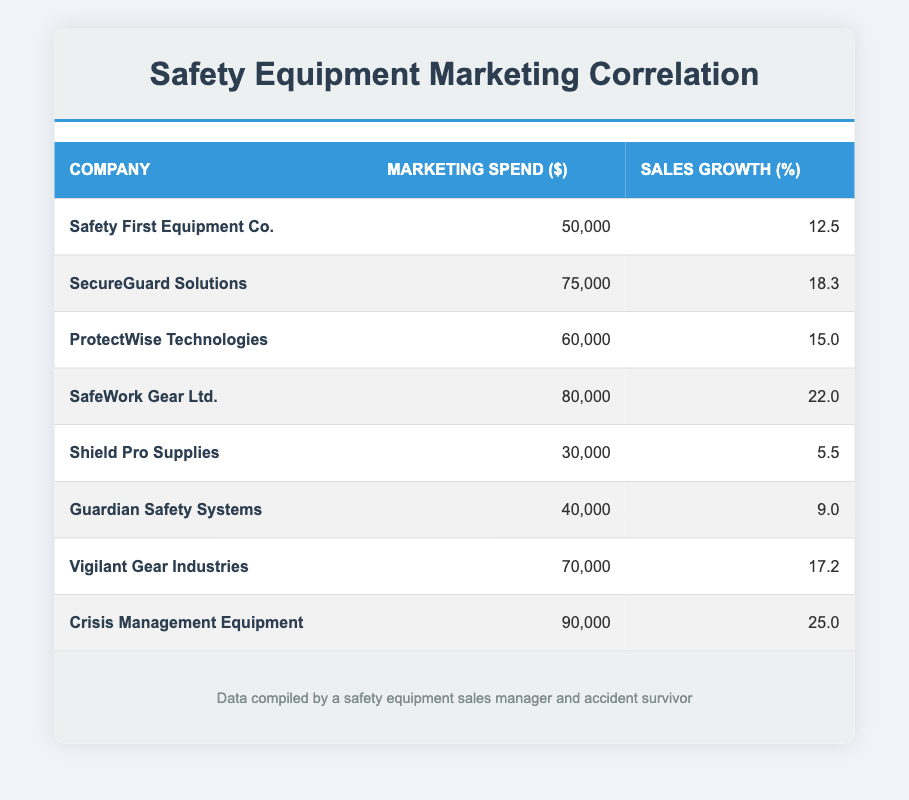What is the marketing spend for SafeWork Gear Ltd.? The table lists SafeWork Gear Ltd. with a marketing spend of $80,000.
Answer: 80,000 Which company has the highest sales growth? The table reveals that Crisis Management Equipment has the highest sales growth at 25.0%.
Answer: 25.0% What is the total marketing spend for the companies with sales growth above 15%? Identify the companies with sales growth above 15%: SecureGuard Solutions (75,000), SafeWork Gear Ltd. (80,000), Vigilant Gear Industries (70,000), and Crisis Management Equipment (90,000). Adding these, the total is 75,000 + 80,000 + 70,000 + 90,000 = 315,000.
Answer: 315,000 Is there a company with marketing spend of exactly 60,000? The table lists ProtectWise Technologies with a marketing spend of $60,000, confirming that this fact is true.
Answer: Yes What is the average sales growth of all companies listed? To find the average, sum the sales growth percentages: 12.5 + 18.3 + 15.0 + 22.0 + 5.5 + 9.0 + 17.2 + 25.0 = 110.5. Divide by the number of companies (8): 110.5 / 8 = 13.81.
Answer: 13.81 